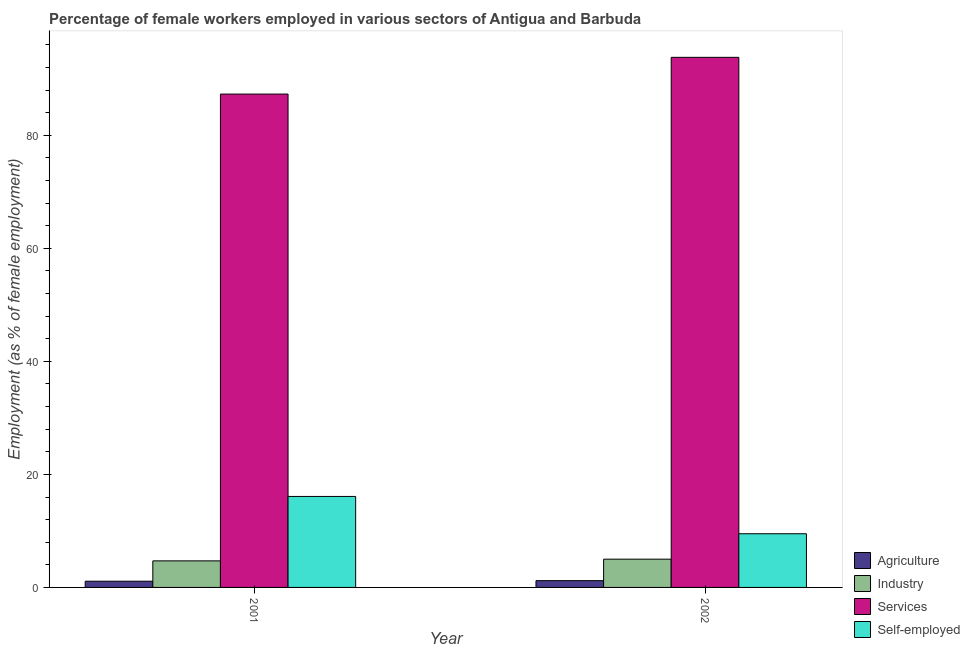Are the number of bars per tick equal to the number of legend labels?
Make the answer very short. Yes. Are the number of bars on each tick of the X-axis equal?
Your response must be concise. Yes. In how many cases, is the number of bars for a given year not equal to the number of legend labels?
Provide a succinct answer. 0. What is the percentage of female workers in agriculture in 2002?
Give a very brief answer. 1.2. Across all years, what is the maximum percentage of female workers in services?
Keep it short and to the point. 93.8. Across all years, what is the minimum percentage of female workers in services?
Give a very brief answer. 87.3. In which year was the percentage of self employed female workers minimum?
Give a very brief answer. 2002. What is the total percentage of female workers in services in the graph?
Provide a short and direct response. 181.1. What is the difference between the percentage of female workers in services in 2001 and that in 2002?
Give a very brief answer. -6.5. What is the difference between the percentage of female workers in agriculture in 2001 and the percentage of self employed female workers in 2002?
Your response must be concise. -0.1. What is the average percentage of female workers in industry per year?
Keep it short and to the point. 4.85. In how many years, is the percentage of female workers in industry greater than 48 %?
Provide a short and direct response. 0. What is the ratio of the percentage of female workers in industry in 2001 to that in 2002?
Provide a short and direct response. 0.94. What does the 1st bar from the left in 2002 represents?
Keep it short and to the point. Agriculture. What does the 2nd bar from the right in 2002 represents?
Your response must be concise. Services. How many bars are there?
Keep it short and to the point. 8. How many years are there in the graph?
Give a very brief answer. 2. What is the difference between two consecutive major ticks on the Y-axis?
Offer a very short reply. 20. Are the values on the major ticks of Y-axis written in scientific E-notation?
Your answer should be compact. No. Does the graph contain grids?
Provide a succinct answer. No. How many legend labels are there?
Provide a succinct answer. 4. How are the legend labels stacked?
Provide a succinct answer. Vertical. What is the title of the graph?
Ensure brevity in your answer.  Percentage of female workers employed in various sectors of Antigua and Barbuda. Does "Debt policy" appear as one of the legend labels in the graph?
Make the answer very short. No. What is the label or title of the X-axis?
Offer a terse response. Year. What is the label or title of the Y-axis?
Offer a terse response. Employment (as % of female employment). What is the Employment (as % of female employment) of Agriculture in 2001?
Offer a very short reply. 1.1. What is the Employment (as % of female employment) in Industry in 2001?
Ensure brevity in your answer.  4.7. What is the Employment (as % of female employment) in Services in 2001?
Give a very brief answer. 87.3. What is the Employment (as % of female employment) of Self-employed in 2001?
Ensure brevity in your answer.  16.1. What is the Employment (as % of female employment) of Agriculture in 2002?
Offer a very short reply. 1.2. What is the Employment (as % of female employment) in Industry in 2002?
Make the answer very short. 5. What is the Employment (as % of female employment) of Services in 2002?
Provide a succinct answer. 93.8. Across all years, what is the maximum Employment (as % of female employment) in Agriculture?
Give a very brief answer. 1.2. Across all years, what is the maximum Employment (as % of female employment) of Industry?
Make the answer very short. 5. Across all years, what is the maximum Employment (as % of female employment) in Services?
Provide a short and direct response. 93.8. Across all years, what is the maximum Employment (as % of female employment) of Self-employed?
Provide a succinct answer. 16.1. Across all years, what is the minimum Employment (as % of female employment) of Agriculture?
Provide a succinct answer. 1.1. Across all years, what is the minimum Employment (as % of female employment) in Industry?
Offer a terse response. 4.7. Across all years, what is the minimum Employment (as % of female employment) in Services?
Keep it short and to the point. 87.3. What is the total Employment (as % of female employment) of Industry in the graph?
Keep it short and to the point. 9.7. What is the total Employment (as % of female employment) of Services in the graph?
Offer a very short reply. 181.1. What is the total Employment (as % of female employment) in Self-employed in the graph?
Ensure brevity in your answer.  25.6. What is the difference between the Employment (as % of female employment) of Self-employed in 2001 and that in 2002?
Your answer should be very brief. 6.6. What is the difference between the Employment (as % of female employment) of Agriculture in 2001 and the Employment (as % of female employment) of Industry in 2002?
Your response must be concise. -3.9. What is the difference between the Employment (as % of female employment) of Agriculture in 2001 and the Employment (as % of female employment) of Services in 2002?
Ensure brevity in your answer.  -92.7. What is the difference between the Employment (as % of female employment) of Industry in 2001 and the Employment (as % of female employment) of Services in 2002?
Provide a short and direct response. -89.1. What is the difference between the Employment (as % of female employment) of Industry in 2001 and the Employment (as % of female employment) of Self-employed in 2002?
Provide a succinct answer. -4.8. What is the difference between the Employment (as % of female employment) in Services in 2001 and the Employment (as % of female employment) in Self-employed in 2002?
Provide a short and direct response. 77.8. What is the average Employment (as % of female employment) of Agriculture per year?
Keep it short and to the point. 1.15. What is the average Employment (as % of female employment) in Industry per year?
Make the answer very short. 4.85. What is the average Employment (as % of female employment) in Services per year?
Your response must be concise. 90.55. In the year 2001, what is the difference between the Employment (as % of female employment) of Agriculture and Employment (as % of female employment) of Services?
Provide a succinct answer. -86.2. In the year 2001, what is the difference between the Employment (as % of female employment) in Agriculture and Employment (as % of female employment) in Self-employed?
Keep it short and to the point. -15. In the year 2001, what is the difference between the Employment (as % of female employment) of Industry and Employment (as % of female employment) of Services?
Make the answer very short. -82.6. In the year 2001, what is the difference between the Employment (as % of female employment) in Industry and Employment (as % of female employment) in Self-employed?
Provide a succinct answer. -11.4. In the year 2001, what is the difference between the Employment (as % of female employment) in Services and Employment (as % of female employment) in Self-employed?
Keep it short and to the point. 71.2. In the year 2002, what is the difference between the Employment (as % of female employment) in Agriculture and Employment (as % of female employment) in Industry?
Your response must be concise. -3.8. In the year 2002, what is the difference between the Employment (as % of female employment) of Agriculture and Employment (as % of female employment) of Services?
Give a very brief answer. -92.6. In the year 2002, what is the difference between the Employment (as % of female employment) of Agriculture and Employment (as % of female employment) of Self-employed?
Make the answer very short. -8.3. In the year 2002, what is the difference between the Employment (as % of female employment) in Industry and Employment (as % of female employment) in Services?
Your response must be concise. -88.8. In the year 2002, what is the difference between the Employment (as % of female employment) of Industry and Employment (as % of female employment) of Self-employed?
Make the answer very short. -4.5. In the year 2002, what is the difference between the Employment (as % of female employment) of Services and Employment (as % of female employment) of Self-employed?
Make the answer very short. 84.3. What is the ratio of the Employment (as % of female employment) of Services in 2001 to that in 2002?
Give a very brief answer. 0.93. What is the ratio of the Employment (as % of female employment) in Self-employed in 2001 to that in 2002?
Your answer should be very brief. 1.69. What is the difference between the highest and the second highest Employment (as % of female employment) of Industry?
Your answer should be very brief. 0.3. What is the difference between the highest and the second highest Employment (as % of female employment) in Services?
Ensure brevity in your answer.  6.5. What is the difference between the highest and the second highest Employment (as % of female employment) in Self-employed?
Keep it short and to the point. 6.6. What is the difference between the highest and the lowest Employment (as % of female employment) in Services?
Keep it short and to the point. 6.5. What is the difference between the highest and the lowest Employment (as % of female employment) in Self-employed?
Provide a succinct answer. 6.6. 